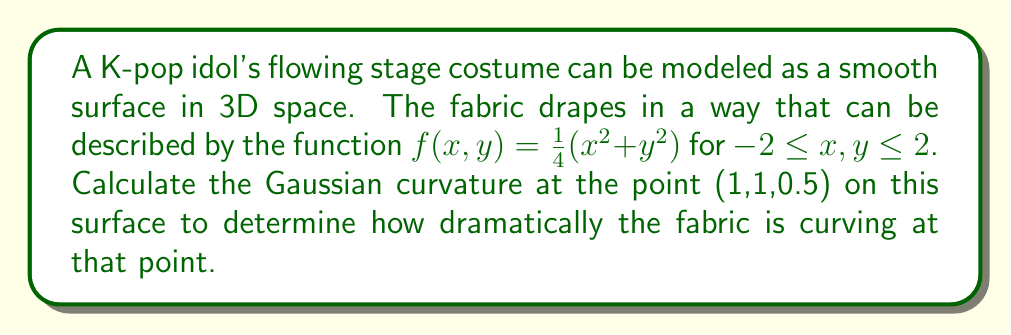What is the answer to this math problem? To find the Gaussian curvature of the surface at the given point, we need to follow these steps:

1) The Gaussian curvature K is given by $K = \frac{LN - M^2}{EG - F^2}$, where L, M, N are coefficients of the second fundamental form, and E, F, G are coefficients of the first fundamental form.

2) First, let's calculate the partial derivatives:
   $f_x = \frac{\partial f}{\partial x} = \frac{1}{2}x$
   $f_y = \frac{\partial f}{\partial y} = \frac{1}{2}y$
   $f_{xx} = \frac{\partial^2 f}{\partial x^2} = \frac{1}{2}$
   $f_{yy} = \frac{\partial^2 f}{\partial y^2} = \frac{1}{2}$
   $f_{xy} = \frac{\partial^2 f}{\partial x\partial y} = 0$

3) Now, we can calculate E, F, and G:
   $E = 1 + f_x^2 = 1 + (\frac{1}{2}x)^2 = 1 + \frac{1}{4}x^2$
   $F = f_x f_y = \frac{1}{4}xy$
   $G = 1 + f_y^2 = 1 + (\frac{1}{2}y)^2 = 1 + \frac{1}{4}y^2$

4) Next, we calculate the unit normal vector:
   $\vec{N} = \frac{(-f_x, -f_y, 1)}{\sqrt{1 + f_x^2 + f_y^2}} = \frac{(-\frac{1}{2}x, -\frac{1}{2}y, 1)}{\sqrt{1 + \frac{1}{4}x^2 + \frac{1}{4}y^2}}$

5) Now we can calculate L, M, and N:
   $L = \frac{f_{xx}}{\sqrt{1 + f_x^2 + f_y^2}} = \frac{\frac{1}{2}}{\sqrt{1 + \frac{1}{4}x^2 + \frac{1}{4}y^2}}$
   $M = \frac{f_{xy}}{\sqrt{1 + f_x^2 + f_y^2}} = 0$
   $N = \frac{f_{yy}}{\sqrt{1 + f_x^2 + f_y^2}} = \frac{\frac{1}{2}}{\sqrt{1 + \frac{1}{4}x^2 + \frac{1}{4}y^2}}$

6) At the point (1,1,0.5), we can now calculate:
   $E = 1 + \frac{1}{4} = \frac{5}{4}$
   $F = \frac{1}{4}$
   $G = \frac{5}{4}$
   $L = N = \frac{\frac{1}{2}}{\sqrt{1 + \frac{1}{4} + \frac{1}{4}}} = \frac{\frac{1}{2}}{\sqrt{\frac{3}{2}}} = \frac{1}{\sqrt{6}}$
   $M = 0$

7) Finally, we can calculate the Gaussian curvature:
   $K = \frac{LN - M^2}{EG - F^2} = \frac{(\frac{1}{\sqrt{6}})(\frac{1}{\sqrt{6}}) - 0^2}{(\frac{5}{4})(\frac{5}{4}) - (\frac{1}{4})^2} = \frac{\frac{1}{6}}{\frac{25}{16} - \frac{1}{16}} = \frac{\frac{1}{6}}{\frac{3}{2}} = \frac{1}{9}$

Therefore, the Gaussian curvature at the point (1,1,0.5) is $\frac{1}{9}$.
Answer: $\frac{1}{9}$ 